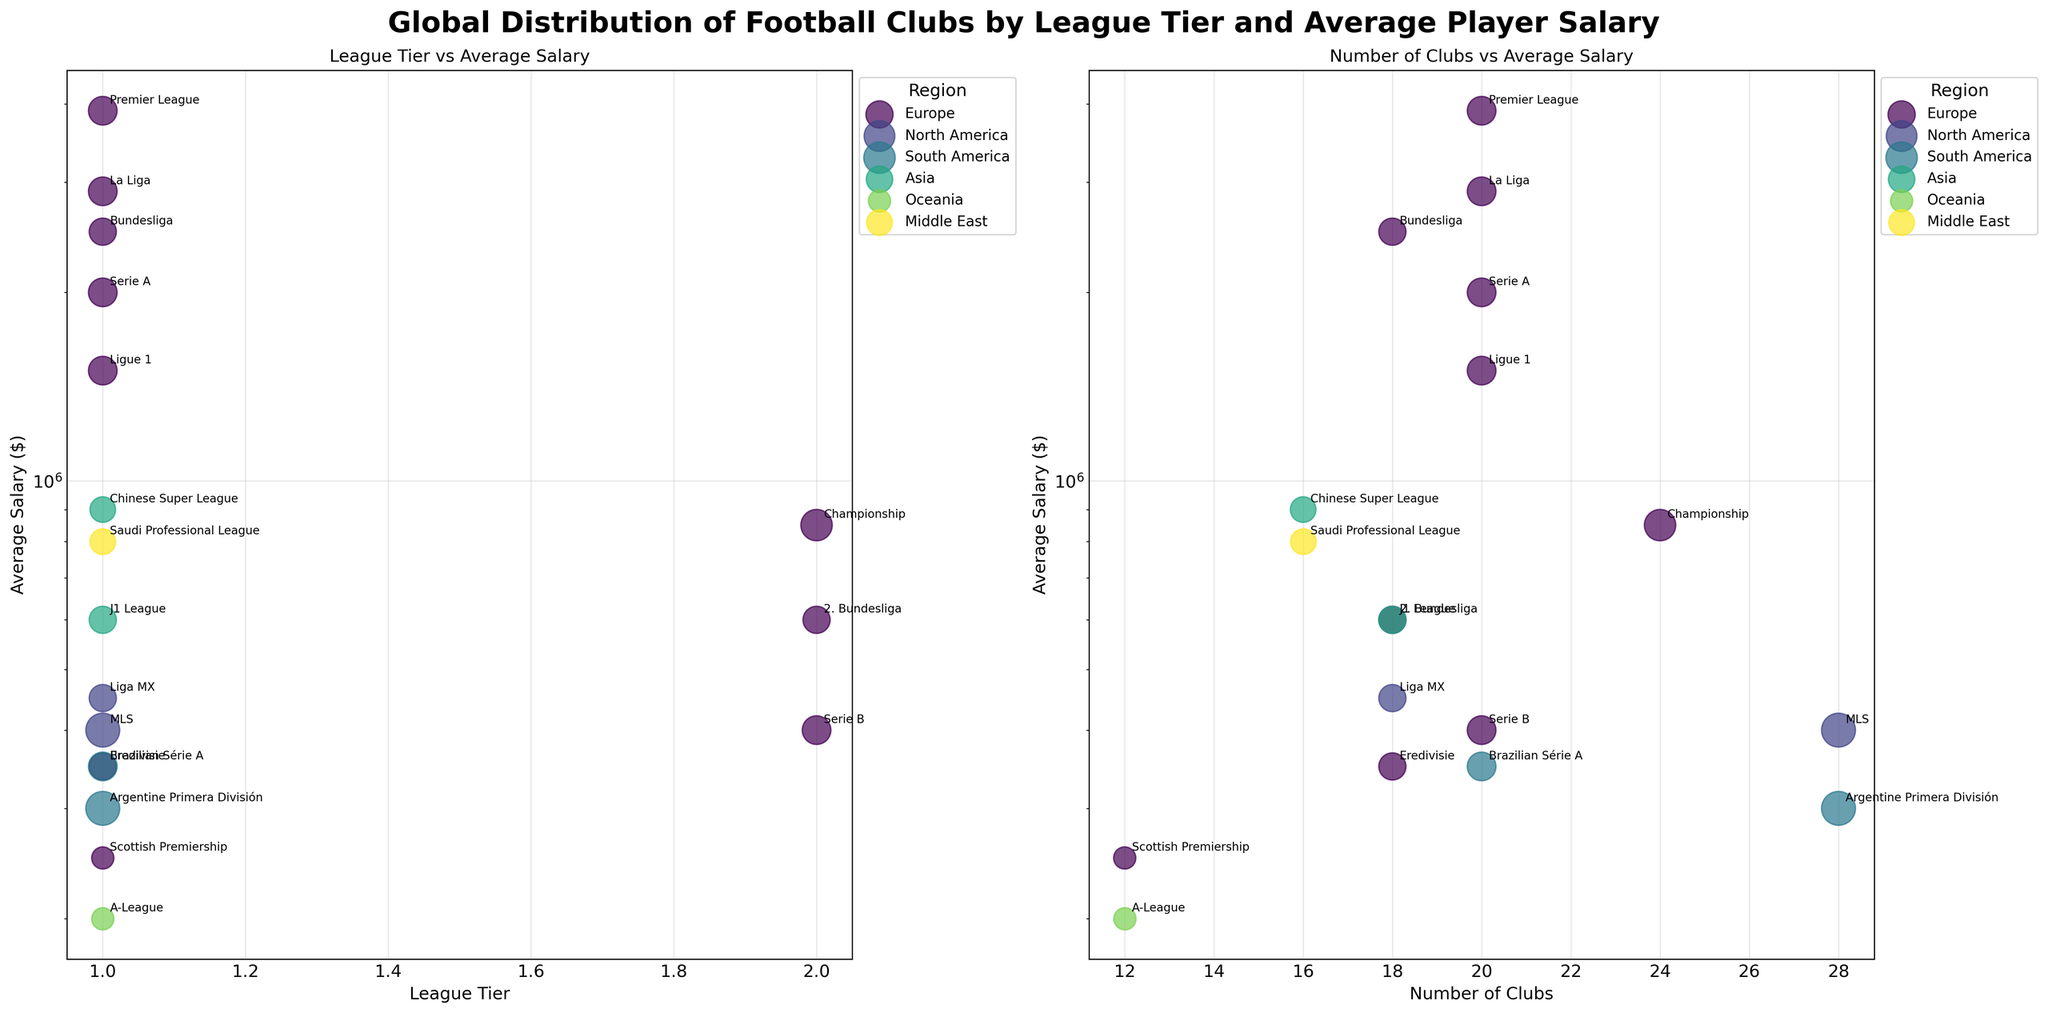What is the title of the figure? The title is located at the top center of the plot. It summarizes the theme of the figure.
Answer: Global Distribution of Football Clubs by League Tier and Average Player Salary How many leagues are represented in the Europe region for the first subplot? Look at the legend to identify the number of unique markers colored for the Europe region in the first subplot.
Answer: 10 Which region has the highest average salary in a Tier 1 league? Find the highest average salary on the y-axis of the first subplot, then identify the corresponding region using the color coding or label.
Answer: Europe (Premier League) How do the average salaries in the MLS compare to those in the Ligue 1? Locate the points for MLS and Ligue 1 in the first subplot, then compare their positions on the y-axis.
Answer: MLS has a lower average salary than Ligue 1 What is the relationship between club count and average salary for the Chinese Super League? Locate the Chinese Super League data point in the second subplot, then observe its position on both the x-axis (club count) and y-axis (average salary).
Answer: Club count is 16, average salary is $900,000 What is the league tier of the league with 24 clubs and an average salary of $850,000? Locate the data point in the first subplot correlating to 24 clubs and an $850,000 salary, then look for the tier.
Answer: 2 (Championship) Which league has the smallest number of clubs in the Oceania region, and what is their average salary? Identify the smallest bubble in the Oceania region on the second subplot and read its associated average salary.
Answer: A-League, $200,000 Is there a league with more than 20 clubs with an average salary above $800,000? If so, which one? Observe the second subplot for bubbles representing more than 20 clubs and check if any are above this average salary threshold.
Answer: Yes, Championship Which region appears to have the most diversity in average player salaries? Compare the spread of data points across the y-axis on both subplots by region.
Answer: Europe 